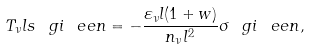<formula> <loc_0><loc_0><loc_500><loc_500>T _ { \nu } l s ^ { \ } g i _ { \ } e e n = - \frac { \varepsilon _ { \nu } l ( 1 + w ) } { n _ { \nu } l ^ { 2 } } \sigma ^ { \ } g i _ { \ } e e n ,</formula> 